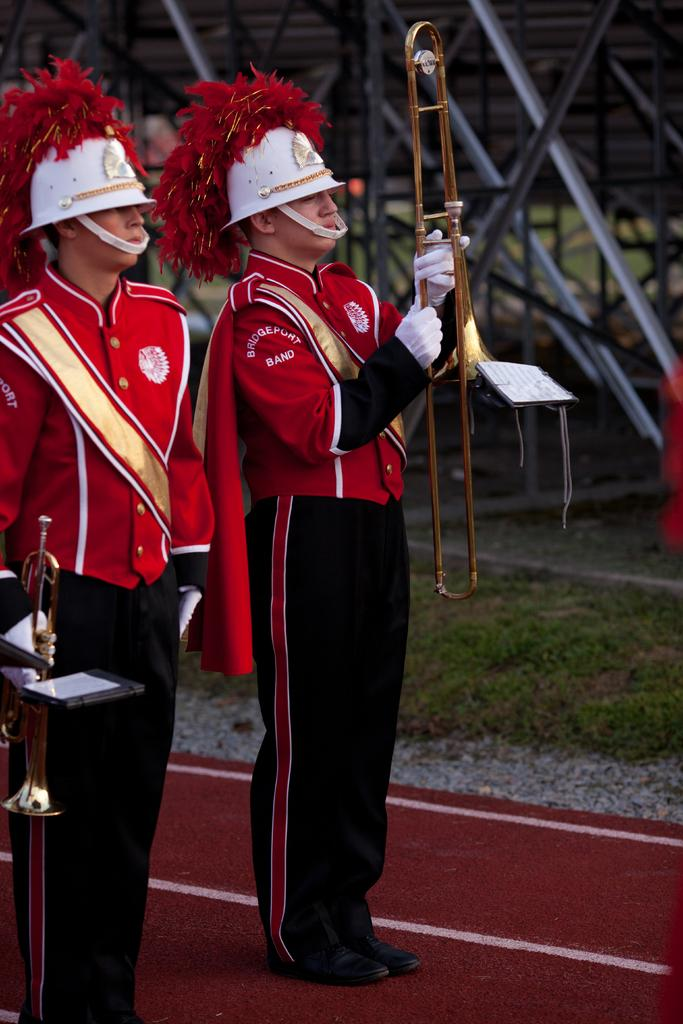<image>
Render a clear and concise summary of the photo. the band playing now is the Bridgeport Band 